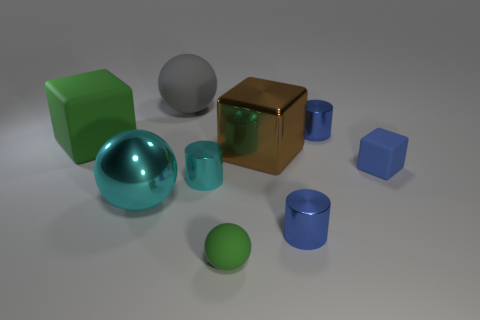Does the large metal block have the same color as the tiny cube?
Your answer should be compact. No. There is a thing that is the same color as the shiny ball; what is its material?
Keep it short and to the point. Metal. Are there the same number of blue cubes that are on the left side of the large cyan metallic sphere and yellow metal blocks?
Provide a succinct answer. Yes. There is a tiny green matte thing; are there any green things on the left side of it?
Your answer should be very brief. Yes. There is a brown thing; is its shape the same as the green object in front of the big green matte cube?
Your answer should be compact. No. There is a big sphere that is made of the same material as the small cube; what is its color?
Your response must be concise. Gray. What color is the big rubber sphere?
Offer a terse response. Gray. Does the tiny ball have the same material as the block that is left of the cyan sphere?
Offer a terse response. Yes. What number of objects are both to the right of the small cyan metallic thing and behind the small green thing?
Offer a terse response. 4. The cyan object that is the same size as the blue matte thing is what shape?
Your answer should be very brief. Cylinder. 